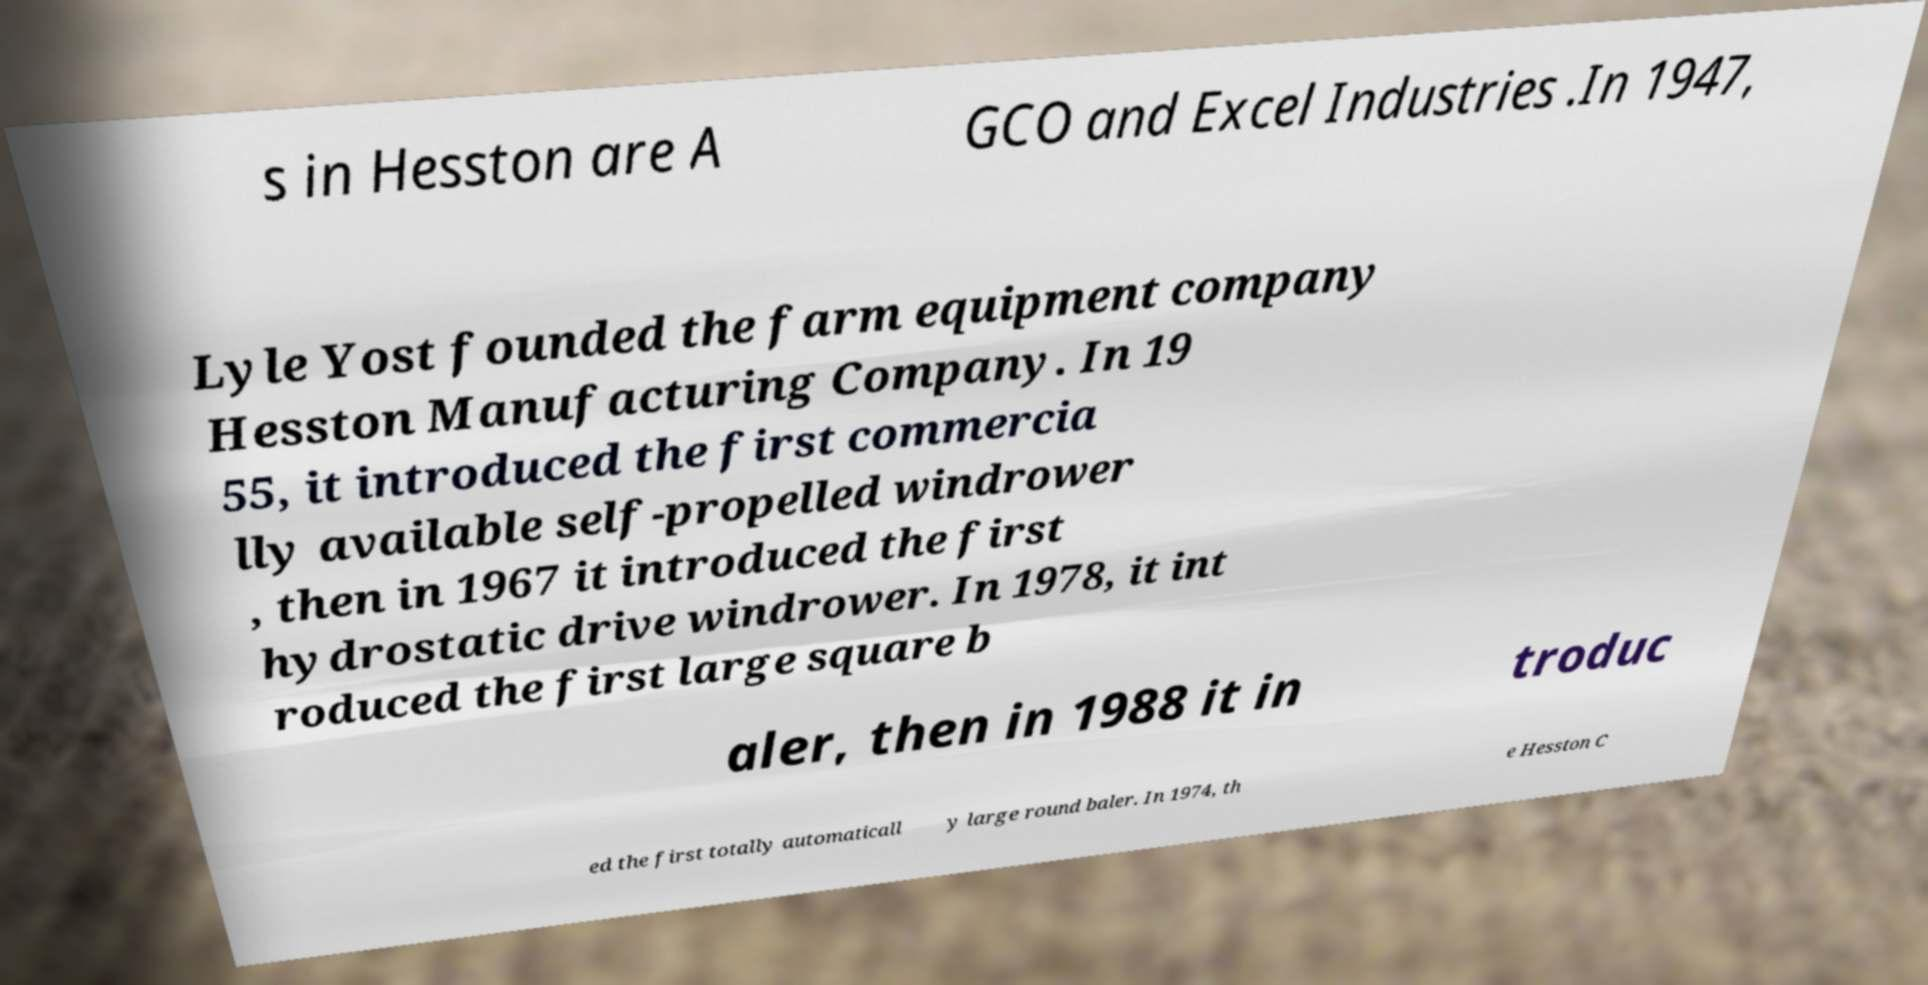What messages or text are displayed in this image? I need them in a readable, typed format. s in Hesston are A GCO and Excel Industries .In 1947, Lyle Yost founded the farm equipment company Hesston Manufacturing Company. In 19 55, it introduced the first commercia lly available self-propelled windrower , then in 1967 it introduced the first hydrostatic drive windrower. In 1978, it int roduced the first large square b aler, then in 1988 it in troduc ed the first totally automaticall y large round baler. In 1974, th e Hesston C 